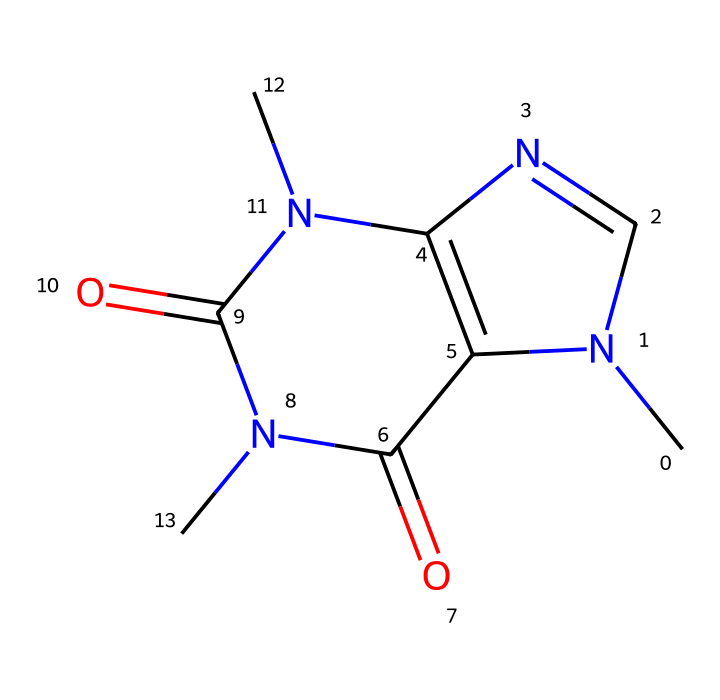What is the molecular formula of caffeine based on its structure? To determine the molecular formula of caffeine from its SMILES representation, analyze the constituent atoms. Counting the carbon (C), nitrogen (N), and oxygen (O) atoms reveals that there are 8 carbon, 10 hydrogen, 4 nitrogen, and 2 oxygen atoms. Combining these counts gives the formula C8H10N4O2.
Answer: C8H10N4O2 How many nitrogen atoms are present in caffeine? From the SMILES representation, nitrogen atoms are represented as "N." By counting all instances of "N" in the structure, we find there are 4 nitrogen atoms.
Answer: 4 What type of bonds are observed in the structure of caffeine? Analyzing the structure, we see both single (—) and double (=) bonds in the chemical structure. Specifically, the N-CH3 bonds and C=O bonds indicate both types of bonding present.
Answer: single and double Does caffeine contain any rings in its chemical structure? By examining the SMILES notation, we note the presence of numbers 1 and 2, which indicate ring formations. Thus, caffeine contains cyclic structures, confirming it has rings.
Answer: yes What functional groups are identified in the structure of caffeine? Reviewing the SMILES structure shows the presence of amine (-NH) groups and carbonyl (C=O) groups, which are key functional groups in alkaloids. Therefore, caffeine has both an amine and carbonyl functional groups.
Answer: amine and carbonyl What is the basic type of alkaloid that caffeine belongs to? Caffeine is classified as a methylxanthine, which is a subclass of alkaloids characterized by the presence of xanthine derivatives with multiple methyl Groups. Therefore, caffeine fits this classification.
Answer: methylxanthine 